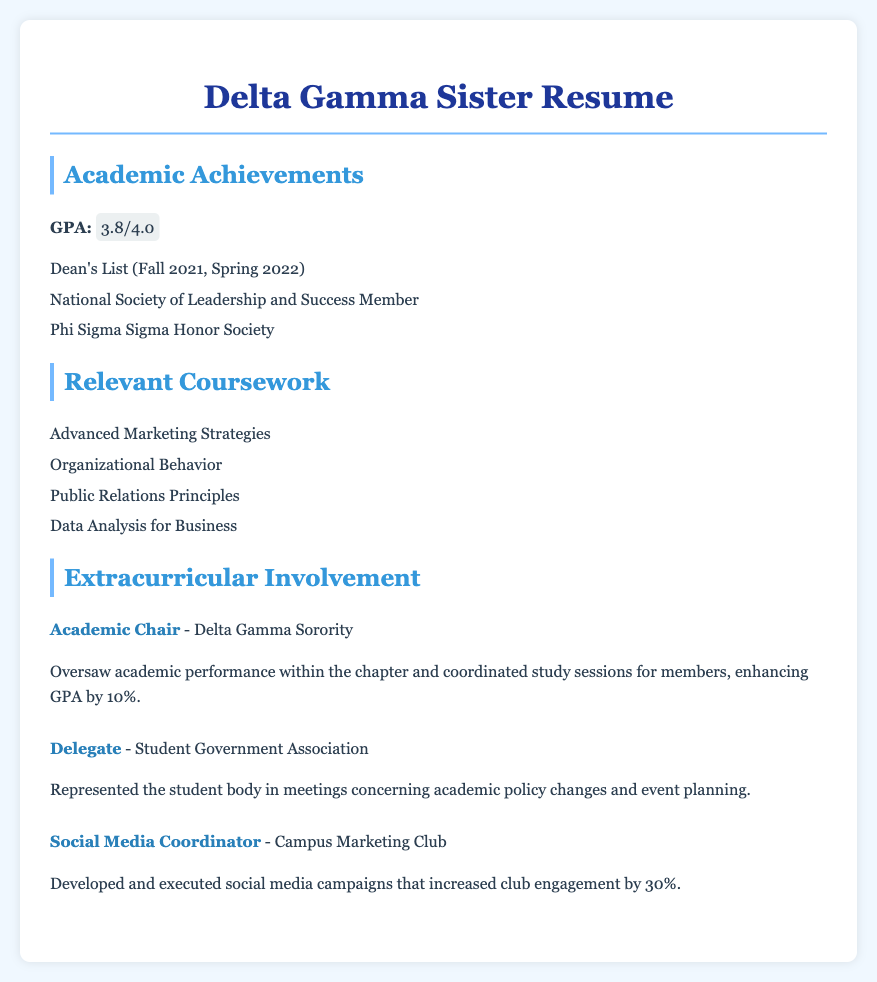What is the GPA? The GPA is specifically mentioned in the document as 3.8 out of a possible 4.0.
Answer: 3.8/4.0 Which honors society is mentioned? The document lists Phi Sigma Sigma Honor Society as one of the honors received.
Answer: Phi Sigma Sigma Honor Society When was the individual on the Dean's List? The document notes the terms in which the individual was on the Dean's List as Fall 2021 and Spring 2022.
Answer: Fall 2021, Spring 2022 What role did the individual hold in the Delta Gamma Sorority? The document states the individual served as the Academic Chair in the Delta Gamma Sorority.
Answer: Academic Chair How much did the GPA improve under the Academic Chair's oversight? The document indicates that the GPA improved by 10% during the Academic Chair's term.
Answer: 10% What is one relevant course related to marketing? The document lists Advanced Marketing Strategies as relevant coursework related to marketing.
Answer: Advanced Marketing Strategies Which organization did the individual represent in academic policy meetings? The document specifies that the individual represented the Student Government Association in meetings.
Answer: Student Government Association By what percentage did social media engagement increase in the Campus Marketing Club? The document shows that engagement increased by 30% due to social media campaigns.
Answer: 30% 